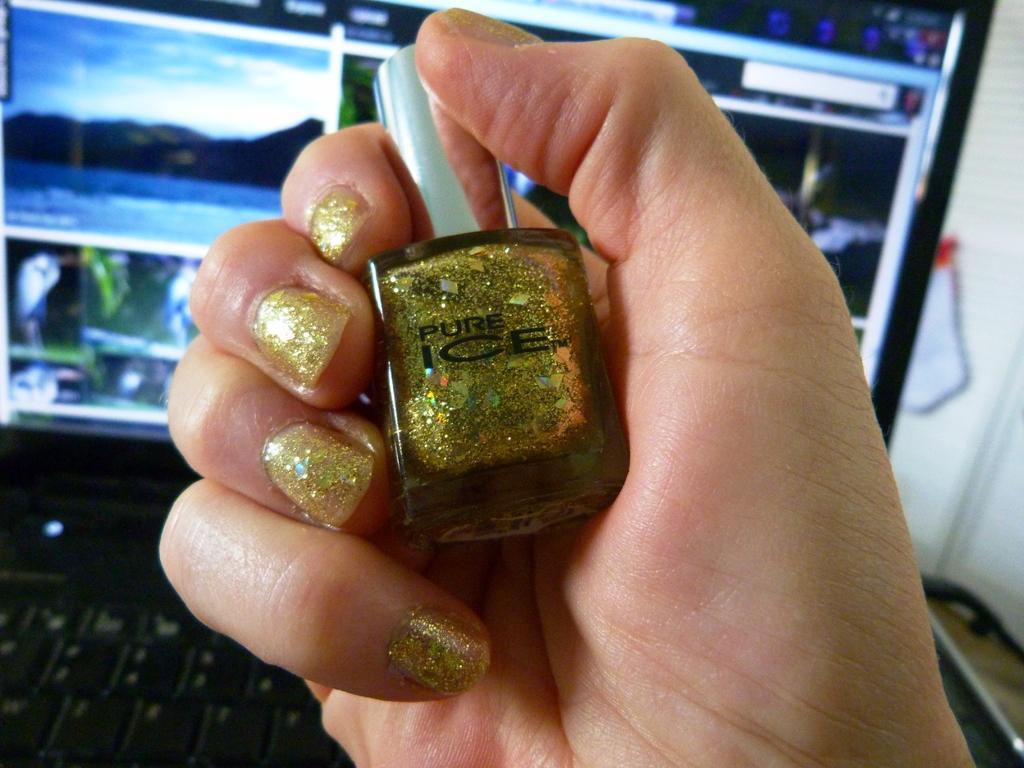Name of this polish?
Your answer should be very brief. Pure ice. 